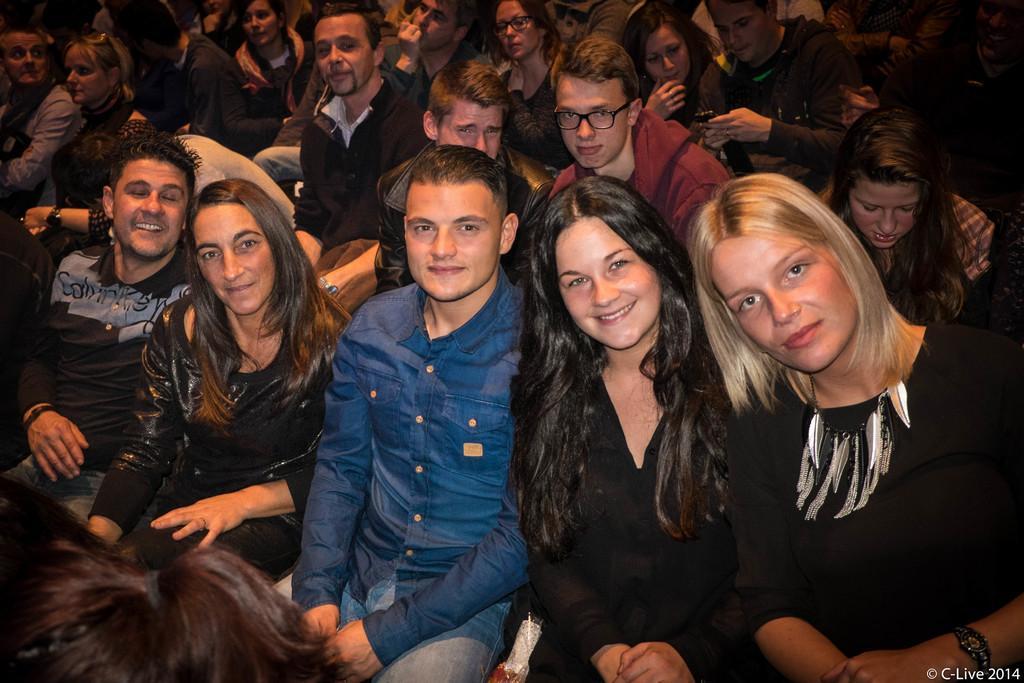Could you give a brief overview of what you see in this image? In this picture we can see group of people, they are all seated, in the bottom right hand corner we can see some text. 